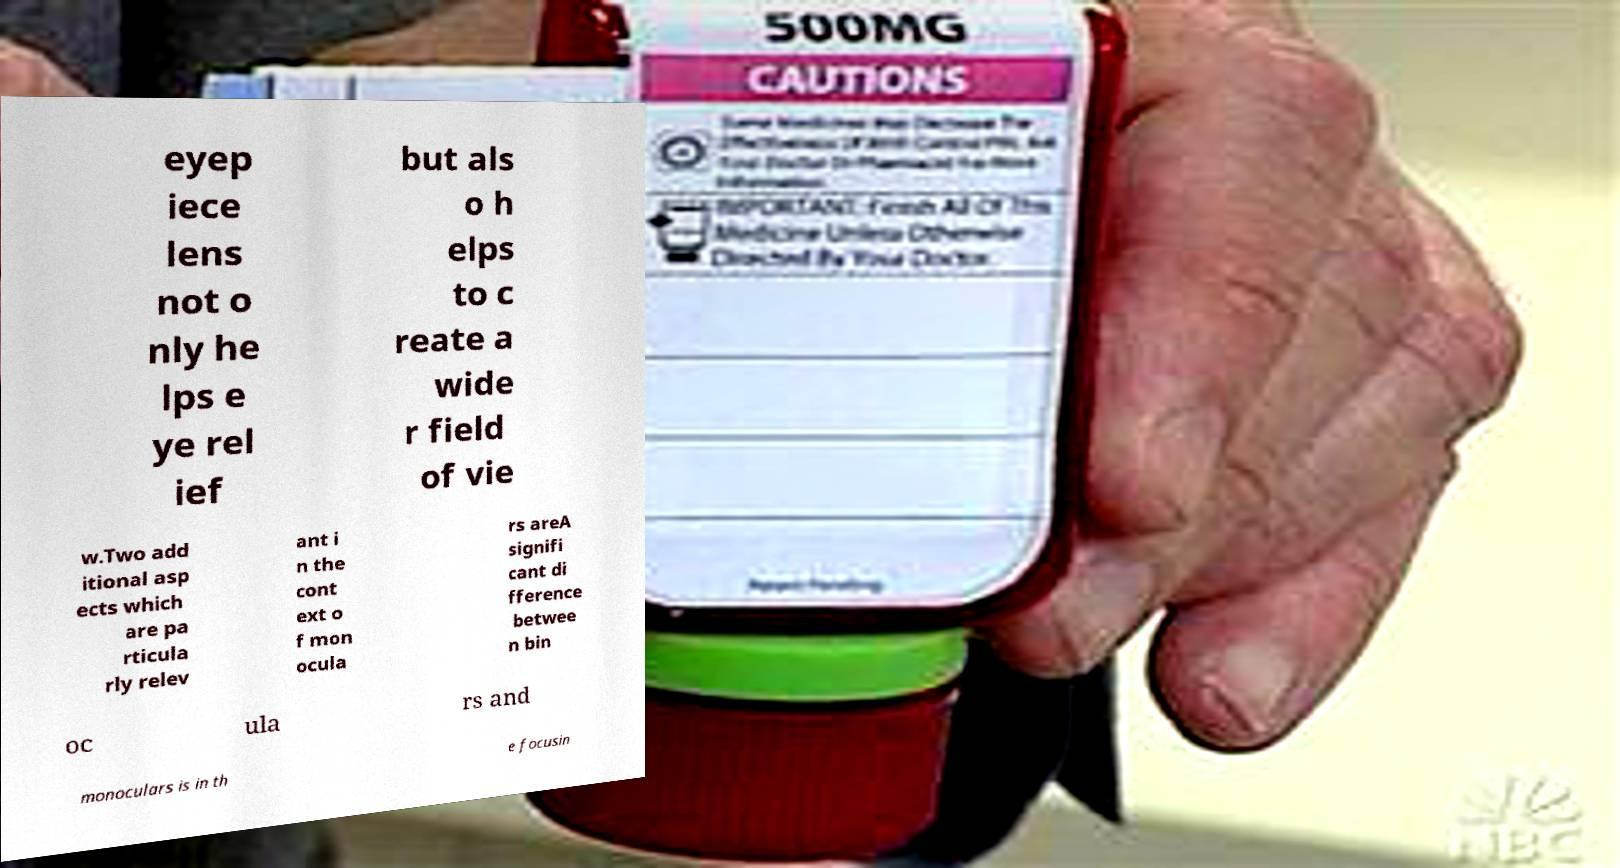Could you assist in decoding the text presented in this image and type it out clearly? eyep iece lens not o nly he lps e ye rel ief but als o h elps to c reate a wide r field of vie w.Two add itional asp ects which are pa rticula rly relev ant i n the cont ext o f mon ocula rs areA signifi cant di fference betwee n bin oc ula rs and monoculars is in th e focusin 